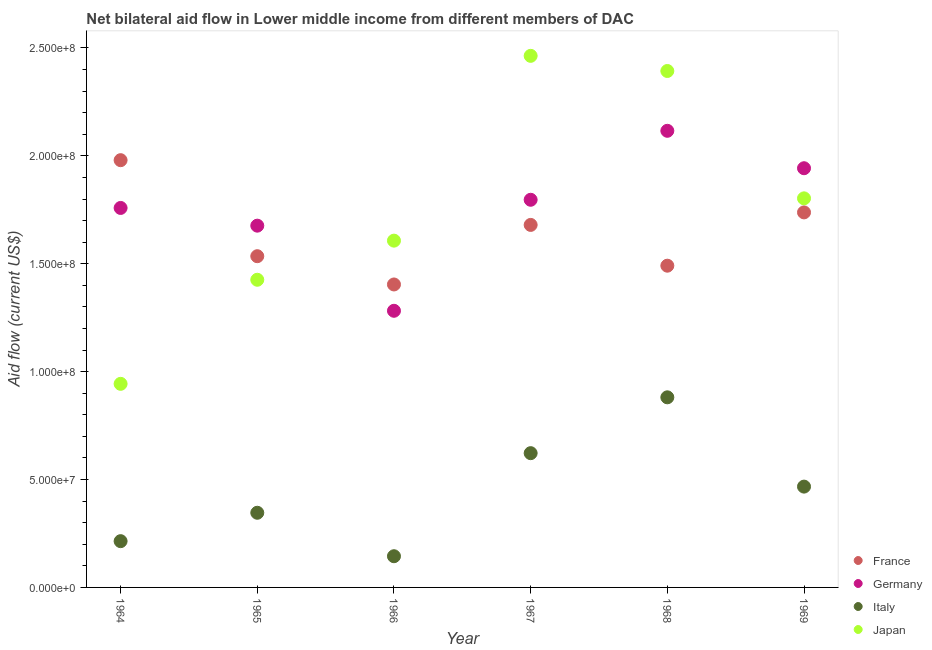How many different coloured dotlines are there?
Your answer should be very brief. 4. What is the amount of aid given by germany in 1965?
Make the answer very short. 1.68e+08. Across all years, what is the maximum amount of aid given by france?
Make the answer very short. 1.98e+08. Across all years, what is the minimum amount of aid given by france?
Give a very brief answer. 1.40e+08. In which year was the amount of aid given by japan maximum?
Your answer should be compact. 1967. In which year was the amount of aid given by italy minimum?
Provide a short and direct response. 1966. What is the total amount of aid given by france in the graph?
Provide a short and direct response. 9.83e+08. What is the difference between the amount of aid given by france in 1964 and that in 1968?
Provide a short and direct response. 4.89e+07. What is the difference between the amount of aid given by japan in 1966 and the amount of aid given by france in 1965?
Your response must be concise. 7.21e+06. What is the average amount of aid given by japan per year?
Your answer should be compact. 1.77e+08. In the year 1964, what is the difference between the amount of aid given by japan and amount of aid given by italy?
Ensure brevity in your answer.  7.29e+07. What is the ratio of the amount of aid given by japan in 1965 to that in 1966?
Provide a short and direct response. 0.89. Is the difference between the amount of aid given by japan in 1966 and 1967 greater than the difference between the amount of aid given by germany in 1966 and 1967?
Make the answer very short. No. What is the difference between the highest and the second highest amount of aid given by italy?
Give a very brief answer. 2.59e+07. What is the difference between the highest and the lowest amount of aid given by italy?
Offer a very short reply. 7.36e+07. How many years are there in the graph?
Offer a very short reply. 6. Does the graph contain grids?
Make the answer very short. No. Where does the legend appear in the graph?
Offer a terse response. Bottom right. How many legend labels are there?
Your answer should be very brief. 4. How are the legend labels stacked?
Offer a terse response. Vertical. What is the title of the graph?
Keep it short and to the point. Net bilateral aid flow in Lower middle income from different members of DAC. Does "Structural Policies" appear as one of the legend labels in the graph?
Ensure brevity in your answer.  No. What is the label or title of the Y-axis?
Provide a short and direct response. Aid flow (current US$). What is the Aid flow (current US$) of France in 1964?
Keep it short and to the point. 1.98e+08. What is the Aid flow (current US$) of Germany in 1964?
Your answer should be compact. 1.76e+08. What is the Aid flow (current US$) of Italy in 1964?
Provide a succinct answer. 2.14e+07. What is the Aid flow (current US$) of Japan in 1964?
Offer a very short reply. 9.44e+07. What is the Aid flow (current US$) of France in 1965?
Provide a succinct answer. 1.54e+08. What is the Aid flow (current US$) of Germany in 1965?
Keep it short and to the point. 1.68e+08. What is the Aid flow (current US$) of Italy in 1965?
Ensure brevity in your answer.  3.46e+07. What is the Aid flow (current US$) of Japan in 1965?
Keep it short and to the point. 1.43e+08. What is the Aid flow (current US$) of France in 1966?
Your answer should be compact. 1.40e+08. What is the Aid flow (current US$) in Germany in 1966?
Give a very brief answer. 1.28e+08. What is the Aid flow (current US$) of Italy in 1966?
Provide a short and direct response. 1.45e+07. What is the Aid flow (current US$) of Japan in 1966?
Give a very brief answer. 1.61e+08. What is the Aid flow (current US$) in France in 1967?
Ensure brevity in your answer.  1.68e+08. What is the Aid flow (current US$) of Germany in 1967?
Provide a succinct answer. 1.80e+08. What is the Aid flow (current US$) of Italy in 1967?
Offer a terse response. 6.22e+07. What is the Aid flow (current US$) in Japan in 1967?
Your response must be concise. 2.46e+08. What is the Aid flow (current US$) in France in 1968?
Offer a terse response. 1.49e+08. What is the Aid flow (current US$) of Germany in 1968?
Your answer should be very brief. 2.12e+08. What is the Aid flow (current US$) in Italy in 1968?
Give a very brief answer. 8.81e+07. What is the Aid flow (current US$) in Japan in 1968?
Keep it short and to the point. 2.39e+08. What is the Aid flow (current US$) of France in 1969?
Your answer should be compact. 1.74e+08. What is the Aid flow (current US$) in Germany in 1969?
Provide a succinct answer. 1.94e+08. What is the Aid flow (current US$) in Italy in 1969?
Offer a very short reply. 4.67e+07. What is the Aid flow (current US$) in Japan in 1969?
Your response must be concise. 1.80e+08. Across all years, what is the maximum Aid flow (current US$) of France?
Provide a short and direct response. 1.98e+08. Across all years, what is the maximum Aid flow (current US$) in Germany?
Your answer should be very brief. 2.12e+08. Across all years, what is the maximum Aid flow (current US$) of Italy?
Your response must be concise. 8.81e+07. Across all years, what is the maximum Aid flow (current US$) in Japan?
Your response must be concise. 2.46e+08. Across all years, what is the minimum Aid flow (current US$) of France?
Keep it short and to the point. 1.40e+08. Across all years, what is the minimum Aid flow (current US$) in Germany?
Your answer should be compact. 1.28e+08. Across all years, what is the minimum Aid flow (current US$) of Italy?
Provide a short and direct response. 1.45e+07. Across all years, what is the minimum Aid flow (current US$) of Japan?
Offer a terse response. 9.44e+07. What is the total Aid flow (current US$) in France in the graph?
Offer a terse response. 9.83e+08. What is the total Aid flow (current US$) of Germany in the graph?
Offer a very short reply. 1.06e+09. What is the total Aid flow (current US$) in Italy in the graph?
Provide a short and direct response. 2.68e+08. What is the total Aid flow (current US$) of Japan in the graph?
Your answer should be very brief. 1.06e+09. What is the difference between the Aid flow (current US$) of France in 1964 and that in 1965?
Offer a terse response. 4.45e+07. What is the difference between the Aid flow (current US$) of Germany in 1964 and that in 1965?
Your answer should be compact. 8.21e+06. What is the difference between the Aid flow (current US$) in Italy in 1964 and that in 1965?
Provide a short and direct response. -1.32e+07. What is the difference between the Aid flow (current US$) of Japan in 1964 and that in 1965?
Ensure brevity in your answer.  -4.82e+07. What is the difference between the Aid flow (current US$) in France in 1964 and that in 1966?
Your answer should be compact. 5.76e+07. What is the difference between the Aid flow (current US$) in Germany in 1964 and that in 1966?
Make the answer very short. 4.77e+07. What is the difference between the Aid flow (current US$) of Italy in 1964 and that in 1966?
Your response must be concise. 6.98e+06. What is the difference between the Aid flow (current US$) in Japan in 1964 and that in 1966?
Your answer should be very brief. -6.64e+07. What is the difference between the Aid flow (current US$) of France in 1964 and that in 1967?
Offer a very short reply. 3.00e+07. What is the difference between the Aid flow (current US$) of Germany in 1964 and that in 1967?
Ensure brevity in your answer.  -3.79e+06. What is the difference between the Aid flow (current US$) of Italy in 1964 and that in 1967?
Your response must be concise. -4.08e+07. What is the difference between the Aid flow (current US$) in Japan in 1964 and that in 1967?
Provide a succinct answer. -1.52e+08. What is the difference between the Aid flow (current US$) in France in 1964 and that in 1968?
Offer a very short reply. 4.89e+07. What is the difference between the Aid flow (current US$) of Germany in 1964 and that in 1968?
Your response must be concise. -3.58e+07. What is the difference between the Aid flow (current US$) of Italy in 1964 and that in 1968?
Keep it short and to the point. -6.67e+07. What is the difference between the Aid flow (current US$) in Japan in 1964 and that in 1968?
Provide a succinct answer. -1.45e+08. What is the difference between the Aid flow (current US$) in France in 1964 and that in 1969?
Your answer should be compact. 2.42e+07. What is the difference between the Aid flow (current US$) in Germany in 1964 and that in 1969?
Your answer should be very brief. -1.84e+07. What is the difference between the Aid flow (current US$) of Italy in 1964 and that in 1969?
Give a very brief answer. -2.53e+07. What is the difference between the Aid flow (current US$) in Japan in 1964 and that in 1969?
Keep it short and to the point. -8.60e+07. What is the difference between the Aid flow (current US$) of France in 1965 and that in 1966?
Offer a terse response. 1.31e+07. What is the difference between the Aid flow (current US$) in Germany in 1965 and that in 1966?
Ensure brevity in your answer.  3.94e+07. What is the difference between the Aid flow (current US$) of Italy in 1965 and that in 1966?
Provide a short and direct response. 2.01e+07. What is the difference between the Aid flow (current US$) in Japan in 1965 and that in 1966?
Offer a very short reply. -1.81e+07. What is the difference between the Aid flow (current US$) of France in 1965 and that in 1967?
Provide a short and direct response. -1.45e+07. What is the difference between the Aid flow (current US$) of Germany in 1965 and that in 1967?
Keep it short and to the point. -1.20e+07. What is the difference between the Aid flow (current US$) in Italy in 1965 and that in 1967?
Give a very brief answer. -2.76e+07. What is the difference between the Aid flow (current US$) of Japan in 1965 and that in 1967?
Give a very brief answer. -1.04e+08. What is the difference between the Aid flow (current US$) in France in 1965 and that in 1968?
Offer a very short reply. 4.40e+06. What is the difference between the Aid flow (current US$) in Germany in 1965 and that in 1968?
Offer a very short reply. -4.40e+07. What is the difference between the Aid flow (current US$) in Italy in 1965 and that in 1968?
Provide a short and direct response. -5.35e+07. What is the difference between the Aid flow (current US$) in Japan in 1965 and that in 1968?
Provide a short and direct response. -9.68e+07. What is the difference between the Aid flow (current US$) of France in 1965 and that in 1969?
Ensure brevity in your answer.  -2.03e+07. What is the difference between the Aid flow (current US$) of Germany in 1965 and that in 1969?
Provide a short and direct response. -2.66e+07. What is the difference between the Aid flow (current US$) of Italy in 1965 and that in 1969?
Your answer should be very brief. -1.21e+07. What is the difference between the Aid flow (current US$) in Japan in 1965 and that in 1969?
Keep it short and to the point. -3.77e+07. What is the difference between the Aid flow (current US$) of France in 1966 and that in 1967?
Make the answer very short. -2.76e+07. What is the difference between the Aid flow (current US$) of Germany in 1966 and that in 1967?
Give a very brief answer. -5.14e+07. What is the difference between the Aid flow (current US$) in Italy in 1966 and that in 1967?
Give a very brief answer. -4.78e+07. What is the difference between the Aid flow (current US$) of Japan in 1966 and that in 1967?
Offer a very short reply. -8.56e+07. What is the difference between the Aid flow (current US$) of France in 1966 and that in 1968?
Keep it short and to the point. -8.70e+06. What is the difference between the Aid flow (current US$) of Germany in 1966 and that in 1968?
Offer a very short reply. -8.34e+07. What is the difference between the Aid flow (current US$) of Italy in 1966 and that in 1968?
Provide a short and direct response. -7.36e+07. What is the difference between the Aid flow (current US$) in Japan in 1966 and that in 1968?
Offer a terse response. -7.86e+07. What is the difference between the Aid flow (current US$) of France in 1966 and that in 1969?
Ensure brevity in your answer.  -3.34e+07. What is the difference between the Aid flow (current US$) of Germany in 1966 and that in 1969?
Keep it short and to the point. -6.61e+07. What is the difference between the Aid flow (current US$) of Italy in 1966 and that in 1969?
Your response must be concise. -3.23e+07. What is the difference between the Aid flow (current US$) in Japan in 1966 and that in 1969?
Provide a short and direct response. -1.96e+07. What is the difference between the Aid flow (current US$) in France in 1967 and that in 1968?
Your response must be concise. 1.89e+07. What is the difference between the Aid flow (current US$) in Germany in 1967 and that in 1968?
Your response must be concise. -3.20e+07. What is the difference between the Aid flow (current US$) of Italy in 1967 and that in 1968?
Your response must be concise. -2.59e+07. What is the difference between the Aid flow (current US$) in Japan in 1967 and that in 1968?
Offer a terse response. 7.02e+06. What is the difference between the Aid flow (current US$) in France in 1967 and that in 1969?
Keep it short and to the point. -5.80e+06. What is the difference between the Aid flow (current US$) of Germany in 1967 and that in 1969?
Ensure brevity in your answer.  -1.46e+07. What is the difference between the Aid flow (current US$) of Italy in 1967 and that in 1969?
Provide a succinct answer. 1.55e+07. What is the difference between the Aid flow (current US$) in Japan in 1967 and that in 1969?
Your response must be concise. 6.60e+07. What is the difference between the Aid flow (current US$) in France in 1968 and that in 1969?
Provide a short and direct response. -2.47e+07. What is the difference between the Aid flow (current US$) in Germany in 1968 and that in 1969?
Your answer should be very brief. 1.73e+07. What is the difference between the Aid flow (current US$) of Italy in 1968 and that in 1969?
Your answer should be very brief. 4.14e+07. What is the difference between the Aid flow (current US$) of Japan in 1968 and that in 1969?
Give a very brief answer. 5.90e+07. What is the difference between the Aid flow (current US$) of France in 1964 and the Aid flow (current US$) of Germany in 1965?
Your response must be concise. 3.04e+07. What is the difference between the Aid flow (current US$) of France in 1964 and the Aid flow (current US$) of Italy in 1965?
Ensure brevity in your answer.  1.63e+08. What is the difference between the Aid flow (current US$) in France in 1964 and the Aid flow (current US$) in Japan in 1965?
Provide a short and direct response. 5.54e+07. What is the difference between the Aid flow (current US$) in Germany in 1964 and the Aid flow (current US$) in Italy in 1965?
Your answer should be compact. 1.41e+08. What is the difference between the Aid flow (current US$) of Germany in 1964 and the Aid flow (current US$) of Japan in 1965?
Your response must be concise. 3.33e+07. What is the difference between the Aid flow (current US$) of Italy in 1964 and the Aid flow (current US$) of Japan in 1965?
Your answer should be compact. -1.21e+08. What is the difference between the Aid flow (current US$) in France in 1964 and the Aid flow (current US$) in Germany in 1966?
Keep it short and to the point. 6.98e+07. What is the difference between the Aid flow (current US$) of France in 1964 and the Aid flow (current US$) of Italy in 1966?
Offer a very short reply. 1.84e+08. What is the difference between the Aid flow (current US$) in France in 1964 and the Aid flow (current US$) in Japan in 1966?
Offer a very short reply. 3.73e+07. What is the difference between the Aid flow (current US$) in Germany in 1964 and the Aid flow (current US$) in Italy in 1966?
Give a very brief answer. 1.61e+08. What is the difference between the Aid flow (current US$) of Germany in 1964 and the Aid flow (current US$) of Japan in 1966?
Offer a terse response. 1.52e+07. What is the difference between the Aid flow (current US$) of Italy in 1964 and the Aid flow (current US$) of Japan in 1966?
Offer a terse response. -1.39e+08. What is the difference between the Aid flow (current US$) of France in 1964 and the Aid flow (current US$) of Germany in 1967?
Provide a short and direct response. 1.84e+07. What is the difference between the Aid flow (current US$) of France in 1964 and the Aid flow (current US$) of Italy in 1967?
Provide a short and direct response. 1.36e+08. What is the difference between the Aid flow (current US$) of France in 1964 and the Aid flow (current US$) of Japan in 1967?
Provide a short and direct response. -4.84e+07. What is the difference between the Aid flow (current US$) of Germany in 1964 and the Aid flow (current US$) of Italy in 1967?
Keep it short and to the point. 1.14e+08. What is the difference between the Aid flow (current US$) of Germany in 1964 and the Aid flow (current US$) of Japan in 1967?
Provide a short and direct response. -7.05e+07. What is the difference between the Aid flow (current US$) in Italy in 1964 and the Aid flow (current US$) in Japan in 1967?
Your answer should be very brief. -2.25e+08. What is the difference between the Aid flow (current US$) in France in 1964 and the Aid flow (current US$) in Germany in 1968?
Provide a short and direct response. -1.36e+07. What is the difference between the Aid flow (current US$) of France in 1964 and the Aid flow (current US$) of Italy in 1968?
Keep it short and to the point. 1.10e+08. What is the difference between the Aid flow (current US$) of France in 1964 and the Aid flow (current US$) of Japan in 1968?
Your answer should be compact. -4.13e+07. What is the difference between the Aid flow (current US$) in Germany in 1964 and the Aid flow (current US$) in Italy in 1968?
Your answer should be compact. 8.78e+07. What is the difference between the Aid flow (current US$) of Germany in 1964 and the Aid flow (current US$) of Japan in 1968?
Your answer should be compact. -6.35e+07. What is the difference between the Aid flow (current US$) in Italy in 1964 and the Aid flow (current US$) in Japan in 1968?
Your answer should be compact. -2.18e+08. What is the difference between the Aid flow (current US$) of France in 1964 and the Aid flow (current US$) of Germany in 1969?
Your response must be concise. 3.73e+06. What is the difference between the Aid flow (current US$) of France in 1964 and the Aid flow (current US$) of Italy in 1969?
Give a very brief answer. 1.51e+08. What is the difference between the Aid flow (current US$) of France in 1964 and the Aid flow (current US$) of Japan in 1969?
Your answer should be compact. 1.77e+07. What is the difference between the Aid flow (current US$) of Germany in 1964 and the Aid flow (current US$) of Italy in 1969?
Provide a short and direct response. 1.29e+08. What is the difference between the Aid flow (current US$) of Germany in 1964 and the Aid flow (current US$) of Japan in 1969?
Keep it short and to the point. -4.45e+06. What is the difference between the Aid flow (current US$) in Italy in 1964 and the Aid flow (current US$) in Japan in 1969?
Your answer should be compact. -1.59e+08. What is the difference between the Aid flow (current US$) in France in 1965 and the Aid flow (current US$) in Germany in 1966?
Give a very brief answer. 2.53e+07. What is the difference between the Aid flow (current US$) of France in 1965 and the Aid flow (current US$) of Italy in 1966?
Give a very brief answer. 1.39e+08. What is the difference between the Aid flow (current US$) in France in 1965 and the Aid flow (current US$) in Japan in 1966?
Your answer should be very brief. -7.21e+06. What is the difference between the Aid flow (current US$) of Germany in 1965 and the Aid flow (current US$) of Italy in 1966?
Provide a succinct answer. 1.53e+08. What is the difference between the Aid flow (current US$) in Germany in 1965 and the Aid flow (current US$) in Japan in 1966?
Your response must be concise. 6.94e+06. What is the difference between the Aid flow (current US$) of Italy in 1965 and the Aid flow (current US$) of Japan in 1966?
Offer a very short reply. -1.26e+08. What is the difference between the Aid flow (current US$) in France in 1965 and the Aid flow (current US$) in Germany in 1967?
Keep it short and to the point. -2.62e+07. What is the difference between the Aid flow (current US$) in France in 1965 and the Aid flow (current US$) in Italy in 1967?
Offer a terse response. 9.13e+07. What is the difference between the Aid flow (current US$) in France in 1965 and the Aid flow (current US$) in Japan in 1967?
Provide a succinct answer. -9.28e+07. What is the difference between the Aid flow (current US$) in Germany in 1965 and the Aid flow (current US$) in Italy in 1967?
Provide a succinct answer. 1.05e+08. What is the difference between the Aid flow (current US$) of Germany in 1965 and the Aid flow (current US$) of Japan in 1967?
Make the answer very short. -7.87e+07. What is the difference between the Aid flow (current US$) in Italy in 1965 and the Aid flow (current US$) in Japan in 1967?
Your answer should be very brief. -2.12e+08. What is the difference between the Aid flow (current US$) of France in 1965 and the Aid flow (current US$) of Germany in 1968?
Ensure brevity in your answer.  -5.81e+07. What is the difference between the Aid flow (current US$) in France in 1965 and the Aid flow (current US$) in Italy in 1968?
Keep it short and to the point. 6.54e+07. What is the difference between the Aid flow (current US$) in France in 1965 and the Aid flow (current US$) in Japan in 1968?
Keep it short and to the point. -8.58e+07. What is the difference between the Aid flow (current US$) in Germany in 1965 and the Aid flow (current US$) in Italy in 1968?
Offer a terse response. 7.96e+07. What is the difference between the Aid flow (current US$) of Germany in 1965 and the Aid flow (current US$) of Japan in 1968?
Provide a succinct answer. -7.17e+07. What is the difference between the Aid flow (current US$) of Italy in 1965 and the Aid flow (current US$) of Japan in 1968?
Your response must be concise. -2.05e+08. What is the difference between the Aid flow (current US$) of France in 1965 and the Aid flow (current US$) of Germany in 1969?
Your answer should be compact. -4.08e+07. What is the difference between the Aid flow (current US$) in France in 1965 and the Aid flow (current US$) in Italy in 1969?
Your answer should be compact. 1.07e+08. What is the difference between the Aid flow (current US$) in France in 1965 and the Aid flow (current US$) in Japan in 1969?
Offer a terse response. -2.68e+07. What is the difference between the Aid flow (current US$) of Germany in 1965 and the Aid flow (current US$) of Italy in 1969?
Make the answer very short. 1.21e+08. What is the difference between the Aid flow (current US$) in Germany in 1965 and the Aid flow (current US$) in Japan in 1969?
Your answer should be very brief. -1.27e+07. What is the difference between the Aid flow (current US$) of Italy in 1965 and the Aid flow (current US$) of Japan in 1969?
Offer a terse response. -1.46e+08. What is the difference between the Aid flow (current US$) of France in 1966 and the Aid flow (current US$) of Germany in 1967?
Provide a short and direct response. -3.92e+07. What is the difference between the Aid flow (current US$) of France in 1966 and the Aid flow (current US$) of Italy in 1967?
Make the answer very short. 7.82e+07. What is the difference between the Aid flow (current US$) in France in 1966 and the Aid flow (current US$) in Japan in 1967?
Ensure brevity in your answer.  -1.06e+08. What is the difference between the Aid flow (current US$) in Germany in 1966 and the Aid flow (current US$) in Italy in 1967?
Keep it short and to the point. 6.60e+07. What is the difference between the Aid flow (current US$) in Germany in 1966 and the Aid flow (current US$) in Japan in 1967?
Provide a succinct answer. -1.18e+08. What is the difference between the Aid flow (current US$) of Italy in 1966 and the Aid flow (current US$) of Japan in 1967?
Provide a short and direct response. -2.32e+08. What is the difference between the Aid flow (current US$) of France in 1966 and the Aid flow (current US$) of Germany in 1968?
Provide a succinct answer. -7.12e+07. What is the difference between the Aid flow (current US$) in France in 1966 and the Aid flow (current US$) in Italy in 1968?
Give a very brief answer. 5.23e+07. What is the difference between the Aid flow (current US$) of France in 1966 and the Aid flow (current US$) of Japan in 1968?
Make the answer very short. -9.89e+07. What is the difference between the Aid flow (current US$) of Germany in 1966 and the Aid flow (current US$) of Italy in 1968?
Provide a short and direct response. 4.01e+07. What is the difference between the Aid flow (current US$) of Germany in 1966 and the Aid flow (current US$) of Japan in 1968?
Give a very brief answer. -1.11e+08. What is the difference between the Aid flow (current US$) in Italy in 1966 and the Aid flow (current US$) in Japan in 1968?
Offer a very short reply. -2.25e+08. What is the difference between the Aid flow (current US$) in France in 1966 and the Aid flow (current US$) in Germany in 1969?
Offer a very short reply. -5.39e+07. What is the difference between the Aid flow (current US$) in France in 1966 and the Aid flow (current US$) in Italy in 1969?
Your response must be concise. 9.37e+07. What is the difference between the Aid flow (current US$) of France in 1966 and the Aid flow (current US$) of Japan in 1969?
Ensure brevity in your answer.  -3.99e+07. What is the difference between the Aid flow (current US$) in Germany in 1966 and the Aid flow (current US$) in Italy in 1969?
Offer a very short reply. 8.15e+07. What is the difference between the Aid flow (current US$) of Germany in 1966 and the Aid flow (current US$) of Japan in 1969?
Your answer should be compact. -5.21e+07. What is the difference between the Aid flow (current US$) of Italy in 1966 and the Aid flow (current US$) of Japan in 1969?
Your answer should be compact. -1.66e+08. What is the difference between the Aid flow (current US$) of France in 1967 and the Aid flow (current US$) of Germany in 1968?
Your answer should be very brief. -4.36e+07. What is the difference between the Aid flow (current US$) of France in 1967 and the Aid flow (current US$) of Italy in 1968?
Your answer should be very brief. 7.99e+07. What is the difference between the Aid flow (current US$) of France in 1967 and the Aid flow (current US$) of Japan in 1968?
Offer a terse response. -7.13e+07. What is the difference between the Aid flow (current US$) of Germany in 1967 and the Aid flow (current US$) of Italy in 1968?
Make the answer very short. 9.16e+07. What is the difference between the Aid flow (current US$) of Germany in 1967 and the Aid flow (current US$) of Japan in 1968?
Your answer should be very brief. -5.97e+07. What is the difference between the Aid flow (current US$) of Italy in 1967 and the Aid flow (current US$) of Japan in 1968?
Offer a very short reply. -1.77e+08. What is the difference between the Aid flow (current US$) in France in 1967 and the Aid flow (current US$) in Germany in 1969?
Ensure brevity in your answer.  -2.63e+07. What is the difference between the Aid flow (current US$) of France in 1967 and the Aid flow (current US$) of Italy in 1969?
Give a very brief answer. 1.21e+08. What is the difference between the Aid flow (current US$) of France in 1967 and the Aid flow (current US$) of Japan in 1969?
Keep it short and to the point. -1.23e+07. What is the difference between the Aid flow (current US$) of Germany in 1967 and the Aid flow (current US$) of Italy in 1969?
Your answer should be very brief. 1.33e+08. What is the difference between the Aid flow (current US$) in Germany in 1967 and the Aid flow (current US$) in Japan in 1969?
Ensure brevity in your answer.  -6.60e+05. What is the difference between the Aid flow (current US$) in Italy in 1967 and the Aid flow (current US$) in Japan in 1969?
Ensure brevity in your answer.  -1.18e+08. What is the difference between the Aid flow (current US$) of France in 1968 and the Aid flow (current US$) of Germany in 1969?
Your answer should be very brief. -4.52e+07. What is the difference between the Aid flow (current US$) in France in 1968 and the Aid flow (current US$) in Italy in 1969?
Give a very brief answer. 1.02e+08. What is the difference between the Aid flow (current US$) in France in 1968 and the Aid flow (current US$) in Japan in 1969?
Ensure brevity in your answer.  -3.12e+07. What is the difference between the Aid flow (current US$) of Germany in 1968 and the Aid flow (current US$) of Italy in 1969?
Make the answer very short. 1.65e+08. What is the difference between the Aid flow (current US$) in Germany in 1968 and the Aid flow (current US$) in Japan in 1969?
Your answer should be very brief. 3.13e+07. What is the difference between the Aid flow (current US$) of Italy in 1968 and the Aid flow (current US$) of Japan in 1969?
Your answer should be very brief. -9.22e+07. What is the average Aid flow (current US$) of France per year?
Offer a very short reply. 1.64e+08. What is the average Aid flow (current US$) of Germany per year?
Ensure brevity in your answer.  1.76e+08. What is the average Aid flow (current US$) in Italy per year?
Make the answer very short. 4.46e+07. What is the average Aid flow (current US$) of Japan per year?
Your response must be concise. 1.77e+08. In the year 1964, what is the difference between the Aid flow (current US$) in France and Aid flow (current US$) in Germany?
Make the answer very short. 2.21e+07. In the year 1964, what is the difference between the Aid flow (current US$) of France and Aid flow (current US$) of Italy?
Your answer should be very brief. 1.77e+08. In the year 1964, what is the difference between the Aid flow (current US$) of France and Aid flow (current US$) of Japan?
Ensure brevity in your answer.  1.04e+08. In the year 1964, what is the difference between the Aid flow (current US$) of Germany and Aid flow (current US$) of Italy?
Provide a succinct answer. 1.54e+08. In the year 1964, what is the difference between the Aid flow (current US$) of Germany and Aid flow (current US$) of Japan?
Keep it short and to the point. 8.15e+07. In the year 1964, what is the difference between the Aid flow (current US$) in Italy and Aid flow (current US$) in Japan?
Ensure brevity in your answer.  -7.29e+07. In the year 1965, what is the difference between the Aid flow (current US$) in France and Aid flow (current US$) in Germany?
Give a very brief answer. -1.42e+07. In the year 1965, what is the difference between the Aid flow (current US$) of France and Aid flow (current US$) of Italy?
Give a very brief answer. 1.19e+08. In the year 1965, what is the difference between the Aid flow (current US$) in France and Aid flow (current US$) in Japan?
Ensure brevity in your answer.  1.09e+07. In the year 1965, what is the difference between the Aid flow (current US$) of Germany and Aid flow (current US$) of Italy?
Your response must be concise. 1.33e+08. In the year 1965, what is the difference between the Aid flow (current US$) in Germany and Aid flow (current US$) in Japan?
Keep it short and to the point. 2.51e+07. In the year 1965, what is the difference between the Aid flow (current US$) in Italy and Aid flow (current US$) in Japan?
Your answer should be compact. -1.08e+08. In the year 1966, what is the difference between the Aid flow (current US$) in France and Aid flow (current US$) in Germany?
Your answer should be very brief. 1.22e+07. In the year 1966, what is the difference between the Aid flow (current US$) of France and Aid flow (current US$) of Italy?
Offer a terse response. 1.26e+08. In the year 1966, what is the difference between the Aid flow (current US$) in France and Aid flow (current US$) in Japan?
Give a very brief answer. -2.03e+07. In the year 1966, what is the difference between the Aid flow (current US$) of Germany and Aid flow (current US$) of Italy?
Ensure brevity in your answer.  1.14e+08. In the year 1966, what is the difference between the Aid flow (current US$) of Germany and Aid flow (current US$) of Japan?
Keep it short and to the point. -3.25e+07. In the year 1966, what is the difference between the Aid flow (current US$) of Italy and Aid flow (current US$) of Japan?
Your answer should be compact. -1.46e+08. In the year 1967, what is the difference between the Aid flow (current US$) in France and Aid flow (current US$) in Germany?
Keep it short and to the point. -1.16e+07. In the year 1967, what is the difference between the Aid flow (current US$) in France and Aid flow (current US$) in Italy?
Provide a succinct answer. 1.06e+08. In the year 1967, what is the difference between the Aid flow (current US$) of France and Aid flow (current US$) of Japan?
Make the answer very short. -7.84e+07. In the year 1967, what is the difference between the Aid flow (current US$) in Germany and Aid flow (current US$) in Italy?
Provide a succinct answer. 1.17e+08. In the year 1967, what is the difference between the Aid flow (current US$) of Germany and Aid flow (current US$) of Japan?
Your answer should be compact. -6.67e+07. In the year 1967, what is the difference between the Aid flow (current US$) of Italy and Aid flow (current US$) of Japan?
Provide a short and direct response. -1.84e+08. In the year 1968, what is the difference between the Aid flow (current US$) of France and Aid flow (current US$) of Germany?
Keep it short and to the point. -6.25e+07. In the year 1968, what is the difference between the Aid flow (current US$) in France and Aid flow (current US$) in Italy?
Give a very brief answer. 6.10e+07. In the year 1968, what is the difference between the Aid flow (current US$) in France and Aid flow (current US$) in Japan?
Make the answer very short. -9.02e+07. In the year 1968, what is the difference between the Aid flow (current US$) of Germany and Aid flow (current US$) of Italy?
Give a very brief answer. 1.24e+08. In the year 1968, what is the difference between the Aid flow (current US$) in Germany and Aid flow (current US$) in Japan?
Ensure brevity in your answer.  -2.77e+07. In the year 1968, what is the difference between the Aid flow (current US$) of Italy and Aid flow (current US$) of Japan?
Provide a short and direct response. -1.51e+08. In the year 1969, what is the difference between the Aid flow (current US$) of France and Aid flow (current US$) of Germany?
Your response must be concise. -2.05e+07. In the year 1969, what is the difference between the Aid flow (current US$) of France and Aid flow (current US$) of Italy?
Give a very brief answer. 1.27e+08. In the year 1969, what is the difference between the Aid flow (current US$) in France and Aid flow (current US$) in Japan?
Your response must be concise. -6.51e+06. In the year 1969, what is the difference between the Aid flow (current US$) of Germany and Aid flow (current US$) of Italy?
Make the answer very short. 1.48e+08. In the year 1969, what is the difference between the Aid flow (current US$) of Germany and Aid flow (current US$) of Japan?
Offer a terse response. 1.40e+07. In the year 1969, what is the difference between the Aid flow (current US$) of Italy and Aid flow (current US$) of Japan?
Your answer should be compact. -1.34e+08. What is the ratio of the Aid flow (current US$) in France in 1964 to that in 1965?
Offer a very short reply. 1.29. What is the ratio of the Aid flow (current US$) of Germany in 1964 to that in 1965?
Keep it short and to the point. 1.05. What is the ratio of the Aid flow (current US$) of Italy in 1964 to that in 1965?
Offer a very short reply. 0.62. What is the ratio of the Aid flow (current US$) in Japan in 1964 to that in 1965?
Your response must be concise. 0.66. What is the ratio of the Aid flow (current US$) in France in 1964 to that in 1966?
Ensure brevity in your answer.  1.41. What is the ratio of the Aid flow (current US$) in Germany in 1964 to that in 1966?
Provide a short and direct response. 1.37. What is the ratio of the Aid flow (current US$) of Italy in 1964 to that in 1966?
Provide a short and direct response. 1.48. What is the ratio of the Aid flow (current US$) of Japan in 1964 to that in 1966?
Provide a succinct answer. 0.59. What is the ratio of the Aid flow (current US$) in France in 1964 to that in 1967?
Ensure brevity in your answer.  1.18. What is the ratio of the Aid flow (current US$) of Germany in 1964 to that in 1967?
Your answer should be compact. 0.98. What is the ratio of the Aid flow (current US$) of Italy in 1964 to that in 1967?
Keep it short and to the point. 0.34. What is the ratio of the Aid flow (current US$) in Japan in 1964 to that in 1967?
Your response must be concise. 0.38. What is the ratio of the Aid flow (current US$) in France in 1964 to that in 1968?
Offer a terse response. 1.33. What is the ratio of the Aid flow (current US$) of Germany in 1964 to that in 1968?
Give a very brief answer. 0.83. What is the ratio of the Aid flow (current US$) of Italy in 1964 to that in 1968?
Your answer should be compact. 0.24. What is the ratio of the Aid flow (current US$) in Japan in 1964 to that in 1968?
Your answer should be very brief. 0.39. What is the ratio of the Aid flow (current US$) in France in 1964 to that in 1969?
Provide a short and direct response. 1.14. What is the ratio of the Aid flow (current US$) of Germany in 1964 to that in 1969?
Provide a short and direct response. 0.91. What is the ratio of the Aid flow (current US$) in Italy in 1964 to that in 1969?
Your response must be concise. 0.46. What is the ratio of the Aid flow (current US$) of Japan in 1964 to that in 1969?
Your response must be concise. 0.52. What is the ratio of the Aid flow (current US$) in France in 1965 to that in 1966?
Offer a terse response. 1.09. What is the ratio of the Aid flow (current US$) in Germany in 1965 to that in 1966?
Give a very brief answer. 1.31. What is the ratio of the Aid flow (current US$) of Italy in 1965 to that in 1966?
Offer a terse response. 2.39. What is the ratio of the Aid flow (current US$) in Japan in 1965 to that in 1966?
Provide a succinct answer. 0.89. What is the ratio of the Aid flow (current US$) in France in 1965 to that in 1967?
Make the answer very short. 0.91. What is the ratio of the Aid flow (current US$) in Germany in 1965 to that in 1967?
Your answer should be very brief. 0.93. What is the ratio of the Aid flow (current US$) of Italy in 1965 to that in 1967?
Your answer should be compact. 0.56. What is the ratio of the Aid flow (current US$) in Japan in 1965 to that in 1967?
Offer a terse response. 0.58. What is the ratio of the Aid flow (current US$) in France in 1965 to that in 1968?
Offer a terse response. 1.03. What is the ratio of the Aid flow (current US$) in Germany in 1965 to that in 1968?
Your response must be concise. 0.79. What is the ratio of the Aid flow (current US$) in Italy in 1965 to that in 1968?
Your answer should be very brief. 0.39. What is the ratio of the Aid flow (current US$) of Japan in 1965 to that in 1968?
Ensure brevity in your answer.  0.6. What is the ratio of the Aid flow (current US$) of France in 1965 to that in 1969?
Offer a very short reply. 0.88. What is the ratio of the Aid flow (current US$) in Germany in 1965 to that in 1969?
Your response must be concise. 0.86. What is the ratio of the Aid flow (current US$) of Italy in 1965 to that in 1969?
Ensure brevity in your answer.  0.74. What is the ratio of the Aid flow (current US$) of Japan in 1965 to that in 1969?
Keep it short and to the point. 0.79. What is the ratio of the Aid flow (current US$) of France in 1966 to that in 1967?
Offer a terse response. 0.84. What is the ratio of the Aid flow (current US$) in Germany in 1966 to that in 1967?
Ensure brevity in your answer.  0.71. What is the ratio of the Aid flow (current US$) in Italy in 1966 to that in 1967?
Provide a succinct answer. 0.23. What is the ratio of the Aid flow (current US$) in Japan in 1966 to that in 1967?
Your answer should be very brief. 0.65. What is the ratio of the Aid flow (current US$) of France in 1966 to that in 1968?
Give a very brief answer. 0.94. What is the ratio of the Aid flow (current US$) of Germany in 1966 to that in 1968?
Give a very brief answer. 0.61. What is the ratio of the Aid flow (current US$) of Italy in 1966 to that in 1968?
Make the answer very short. 0.16. What is the ratio of the Aid flow (current US$) in Japan in 1966 to that in 1968?
Ensure brevity in your answer.  0.67. What is the ratio of the Aid flow (current US$) in France in 1966 to that in 1969?
Your answer should be compact. 0.81. What is the ratio of the Aid flow (current US$) in Germany in 1966 to that in 1969?
Your response must be concise. 0.66. What is the ratio of the Aid flow (current US$) of Italy in 1966 to that in 1969?
Provide a short and direct response. 0.31. What is the ratio of the Aid flow (current US$) of Japan in 1966 to that in 1969?
Provide a succinct answer. 0.89. What is the ratio of the Aid flow (current US$) of France in 1967 to that in 1968?
Give a very brief answer. 1.13. What is the ratio of the Aid flow (current US$) in Germany in 1967 to that in 1968?
Offer a very short reply. 0.85. What is the ratio of the Aid flow (current US$) of Italy in 1967 to that in 1968?
Make the answer very short. 0.71. What is the ratio of the Aid flow (current US$) of Japan in 1967 to that in 1968?
Your response must be concise. 1.03. What is the ratio of the Aid flow (current US$) of France in 1967 to that in 1969?
Provide a short and direct response. 0.97. What is the ratio of the Aid flow (current US$) of Germany in 1967 to that in 1969?
Ensure brevity in your answer.  0.92. What is the ratio of the Aid flow (current US$) of Italy in 1967 to that in 1969?
Offer a very short reply. 1.33. What is the ratio of the Aid flow (current US$) of Japan in 1967 to that in 1969?
Keep it short and to the point. 1.37. What is the ratio of the Aid flow (current US$) of France in 1968 to that in 1969?
Provide a short and direct response. 0.86. What is the ratio of the Aid flow (current US$) in Germany in 1968 to that in 1969?
Your answer should be compact. 1.09. What is the ratio of the Aid flow (current US$) in Italy in 1968 to that in 1969?
Your answer should be compact. 1.89. What is the ratio of the Aid flow (current US$) of Japan in 1968 to that in 1969?
Provide a short and direct response. 1.33. What is the difference between the highest and the second highest Aid flow (current US$) of France?
Ensure brevity in your answer.  2.42e+07. What is the difference between the highest and the second highest Aid flow (current US$) in Germany?
Offer a terse response. 1.73e+07. What is the difference between the highest and the second highest Aid flow (current US$) in Italy?
Offer a very short reply. 2.59e+07. What is the difference between the highest and the second highest Aid flow (current US$) of Japan?
Ensure brevity in your answer.  7.02e+06. What is the difference between the highest and the lowest Aid flow (current US$) in France?
Your response must be concise. 5.76e+07. What is the difference between the highest and the lowest Aid flow (current US$) of Germany?
Your answer should be very brief. 8.34e+07. What is the difference between the highest and the lowest Aid flow (current US$) of Italy?
Your answer should be very brief. 7.36e+07. What is the difference between the highest and the lowest Aid flow (current US$) of Japan?
Your response must be concise. 1.52e+08. 